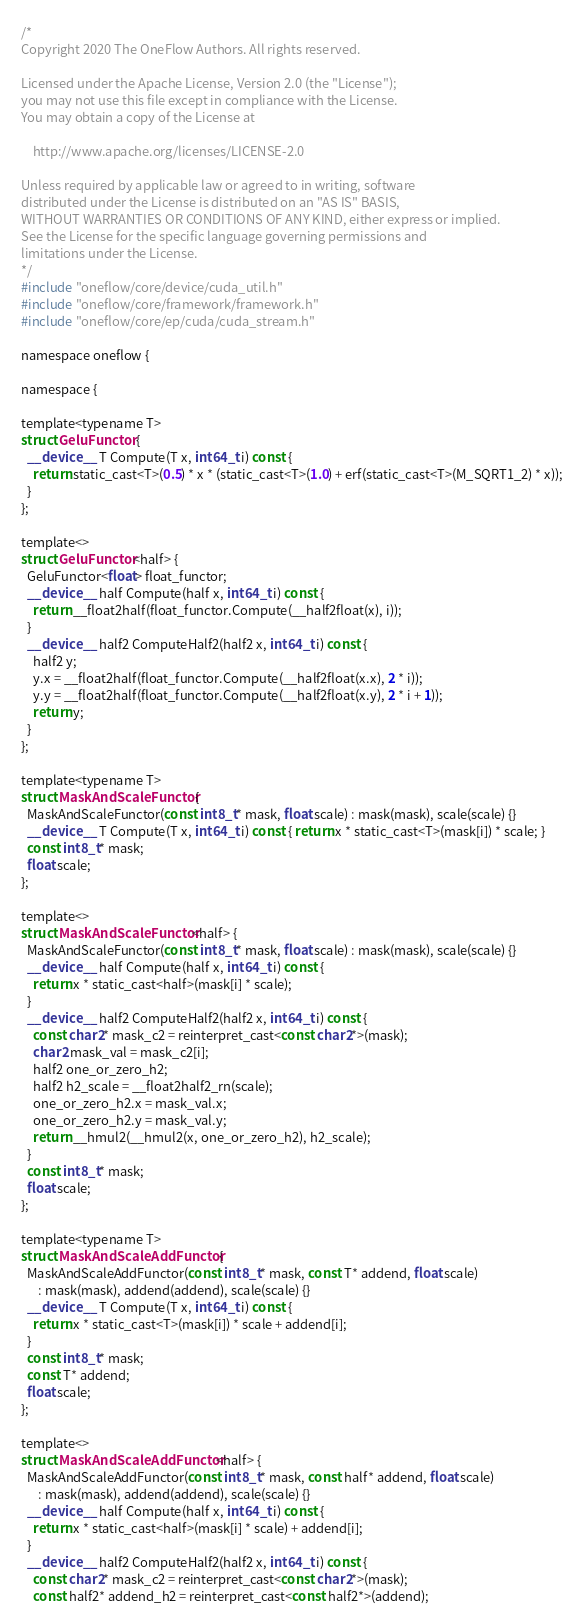Convert code to text. <code><loc_0><loc_0><loc_500><loc_500><_Cuda_>/*
Copyright 2020 The OneFlow Authors. All rights reserved.

Licensed under the Apache License, Version 2.0 (the "License");
you may not use this file except in compliance with the License.
You may obtain a copy of the License at

    http://www.apache.org/licenses/LICENSE-2.0

Unless required by applicable law or agreed to in writing, software
distributed under the License is distributed on an "AS IS" BASIS,
WITHOUT WARRANTIES OR CONDITIONS OF ANY KIND, either express or implied.
See the License for the specific language governing permissions and
limitations under the License.
*/
#include "oneflow/core/device/cuda_util.h"
#include "oneflow/core/framework/framework.h"
#include "oneflow/core/ep/cuda/cuda_stream.h"

namespace oneflow {

namespace {

template<typename T>
struct GeluFunctor {
  __device__ T Compute(T x, int64_t i) const {
    return static_cast<T>(0.5) * x * (static_cast<T>(1.0) + erf(static_cast<T>(M_SQRT1_2) * x));
  }
};

template<>
struct GeluFunctor<half> {
  GeluFunctor<float> float_functor;
  __device__ half Compute(half x, int64_t i) const {
    return __float2half(float_functor.Compute(__half2float(x), i));
  }
  __device__ half2 ComputeHalf2(half2 x, int64_t i) const {
    half2 y;
    y.x = __float2half(float_functor.Compute(__half2float(x.x), 2 * i));
    y.y = __float2half(float_functor.Compute(__half2float(x.y), 2 * i + 1));
    return y;
  }
};

template<typename T>
struct MaskAndScaleFunctor {
  MaskAndScaleFunctor(const int8_t* mask, float scale) : mask(mask), scale(scale) {}
  __device__ T Compute(T x, int64_t i) const { return x * static_cast<T>(mask[i]) * scale; }
  const int8_t* mask;
  float scale;
};

template<>
struct MaskAndScaleFunctor<half> {
  MaskAndScaleFunctor(const int8_t* mask, float scale) : mask(mask), scale(scale) {}
  __device__ half Compute(half x, int64_t i) const {
    return x * static_cast<half>(mask[i] * scale);
  }
  __device__ half2 ComputeHalf2(half2 x, int64_t i) const {
    const char2* mask_c2 = reinterpret_cast<const char2*>(mask);
    char2 mask_val = mask_c2[i];
    half2 one_or_zero_h2;
    half2 h2_scale = __float2half2_rn(scale);
    one_or_zero_h2.x = mask_val.x;
    one_or_zero_h2.y = mask_val.y;
    return __hmul2(__hmul2(x, one_or_zero_h2), h2_scale);
  }
  const int8_t* mask;
  float scale;
};

template<typename T>
struct MaskAndScaleAddFunctor {
  MaskAndScaleAddFunctor(const int8_t* mask, const T* addend, float scale)
      : mask(mask), addend(addend), scale(scale) {}
  __device__ T Compute(T x, int64_t i) const {
    return x * static_cast<T>(mask[i]) * scale + addend[i];
  }
  const int8_t* mask;
  const T* addend;
  float scale;
};

template<>
struct MaskAndScaleAddFunctor<half> {
  MaskAndScaleAddFunctor(const int8_t* mask, const half* addend, float scale)
      : mask(mask), addend(addend), scale(scale) {}
  __device__ half Compute(half x, int64_t i) const {
    return x * static_cast<half>(mask[i] * scale) + addend[i];
  }
  __device__ half2 ComputeHalf2(half2 x, int64_t i) const {
    const char2* mask_c2 = reinterpret_cast<const char2*>(mask);
    const half2* addend_h2 = reinterpret_cast<const half2*>(addend);</code> 